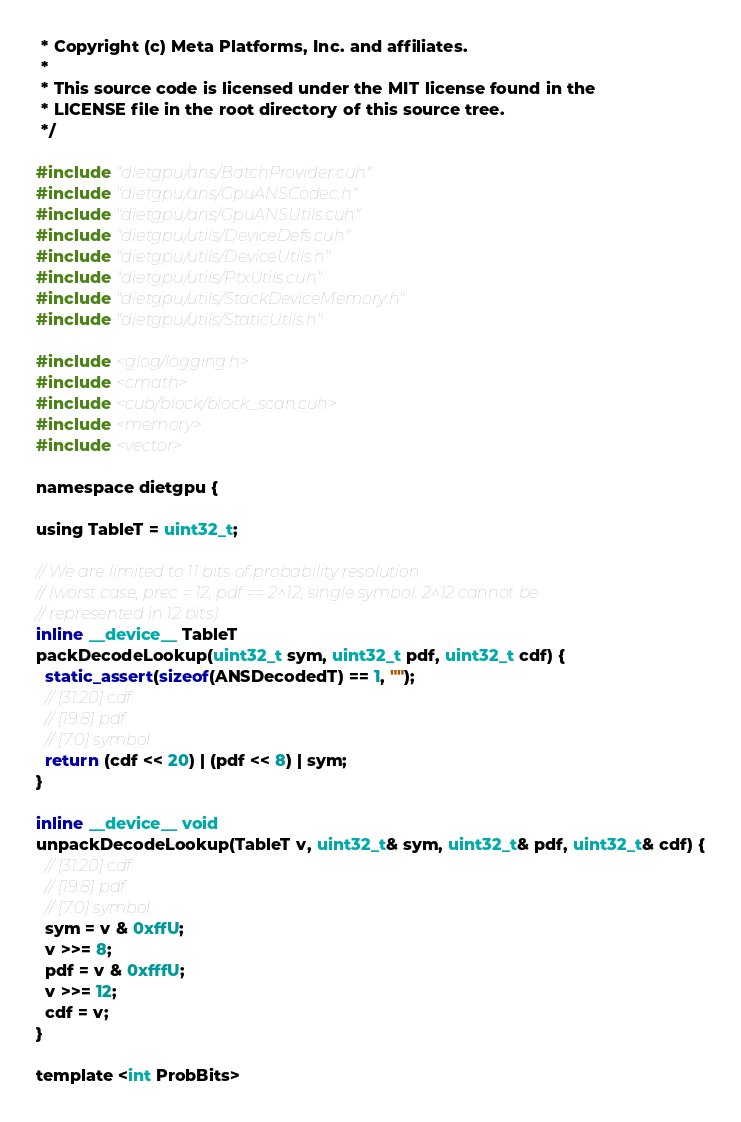<code> <loc_0><loc_0><loc_500><loc_500><_Cuda_> * Copyright (c) Meta Platforms, Inc. and affiliates.
 *
 * This source code is licensed under the MIT license found in the
 * LICENSE file in the root directory of this source tree.
 */

#include "dietgpu/ans/BatchProvider.cuh"
#include "dietgpu/ans/GpuANSCodec.h"
#include "dietgpu/ans/GpuANSUtils.cuh"
#include "dietgpu/utils/DeviceDefs.cuh"
#include "dietgpu/utils/DeviceUtils.h"
#include "dietgpu/utils/PtxUtils.cuh"
#include "dietgpu/utils/StackDeviceMemory.h"
#include "dietgpu/utils/StaticUtils.h"

#include <glog/logging.h>
#include <cmath>
#include <cub/block/block_scan.cuh>
#include <memory>
#include <vector>

namespace dietgpu {

using TableT = uint32_t;

// We are limited to 11 bits of probability resolution
// (worst case, prec = 12, pdf == 2^12, single symbol. 2^12 cannot be
// represented in 12 bits)
inline __device__ TableT
packDecodeLookup(uint32_t sym, uint32_t pdf, uint32_t cdf) {
  static_assert(sizeof(ANSDecodedT) == 1, "");
  // [31:20] cdf
  // [19:8] pdf
  // [7:0] symbol
  return (cdf << 20) | (pdf << 8) | sym;
}

inline __device__ void
unpackDecodeLookup(TableT v, uint32_t& sym, uint32_t& pdf, uint32_t& cdf) {
  // [31:20] cdf
  // [19:8] pdf
  // [7:0] symbol
  sym = v & 0xffU;
  v >>= 8;
  pdf = v & 0xfffU;
  v >>= 12;
  cdf = v;
}

template <int ProbBits></code> 